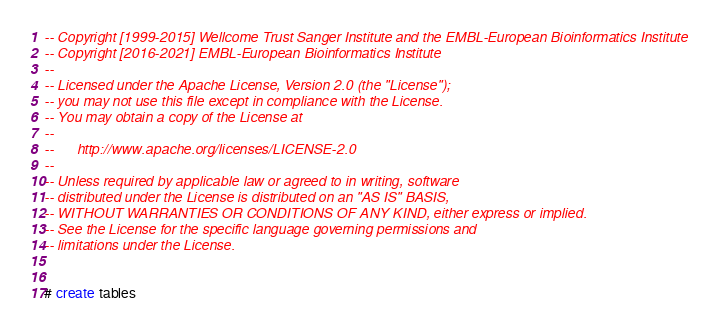<code> <loc_0><loc_0><loc_500><loc_500><_SQL_>-- Copyright [1999-2015] Wellcome Trust Sanger Institute and the EMBL-European Bioinformatics Institute
-- Copyright [2016-2021] EMBL-European Bioinformatics Institute
-- 
-- Licensed under the Apache License, Version 2.0 (the "License");
-- you may not use this file except in compliance with the License.
-- You may obtain a copy of the License at
-- 
--      http://www.apache.org/licenses/LICENSE-2.0
-- 
-- Unless required by applicable law or agreed to in writing, software
-- distributed under the License is distributed on an "AS IS" BASIS,
-- WITHOUT WARRANTIES OR CONDITIONS OF ANY KIND, either express or implied.
-- See the License for the specific language governing permissions and
-- limitations under the License.


# create tables
</code> 